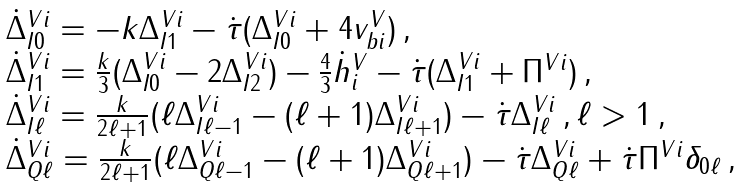Convert formula to latex. <formula><loc_0><loc_0><loc_500><loc_500>\begin{array} { l } \dot { \Delta } ^ { V i } _ { I 0 } = - k \Delta ^ { V i } _ { I 1 } - \dot { \tau } ( \Delta ^ { V i } _ { I 0 } + 4 v _ { b i } ^ { V } ) \, , \\ \dot { \Delta } ^ { V i } _ { I 1 } = \frac { k } { 3 } ( \Delta ^ { V i } _ { I 0 } - 2 \Delta ^ { V i } _ { I 2 } ) - \frac { 4 } { 3 } \dot { h } ^ { V } _ { i } - \dot { \tau } ( \Delta ^ { V i } _ { I 1 } + \Pi ^ { V i } ) \, , \\ \dot { \Delta } ^ { V i } _ { I \ell } = \frac { k } { 2 \ell + 1 } ( \ell \Delta ^ { V i } _ { I \ell - 1 } - ( \ell + 1 ) \Delta ^ { V i } _ { I \ell + 1 } ) - \dot { \tau } \Delta ^ { V i } _ { I \ell } \, , \ell > 1 \, , \\ \dot { \Delta } ^ { V i } _ { Q \ell } = \frac { k } { 2 \ell + 1 } ( \ell \Delta ^ { V i } _ { Q \ell - 1 } - ( \ell + 1 ) \Delta ^ { V i } _ { Q \ell + 1 } ) - \dot { \tau } \Delta ^ { V i } _ { Q \ell } + \dot { \tau } \Pi ^ { V i } \delta _ { 0 \ell } \, , \end{array}</formula> 